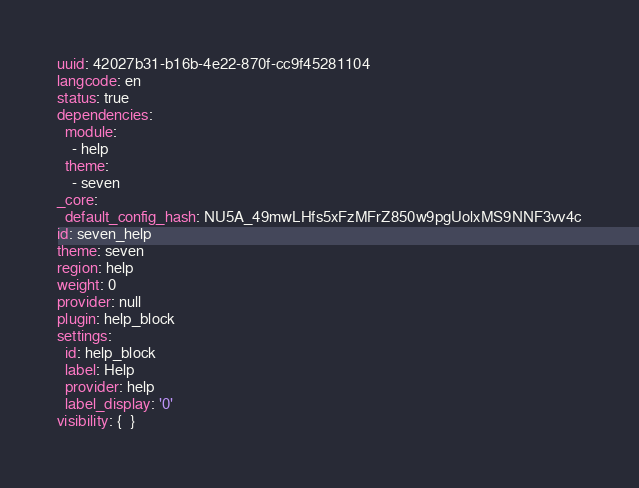<code> <loc_0><loc_0><loc_500><loc_500><_YAML_>uuid: 42027b31-b16b-4e22-870f-cc9f45281104
langcode: en
status: true
dependencies:
  module:
    - help
  theme:
    - seven
_core:
  default_config_hash: NU5A_49mwLHfs5xFzMFrZ850w9pgUolxMS9NNF3vv4c
id: seven_help
theme: seven
region: help
weight: 0
provider: null
plugin: help_block
settings:
  id: help_block
  label: Help
  provider: help
  label_display: '0'
visibility: {  }
</code> 